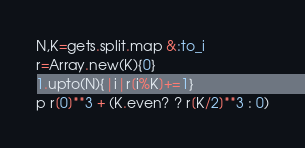Convert code to text. <code><loc_0><loc_0><loc_500><loc_500><_Ruby_>N,K=gets.split.map &:to_i
r=Array.new(K){0}
1.upto(N){|i|r[i%K]+=1}
p r[0]**3 + (K.even? ? r[K/2]**3 : 0)</code> 